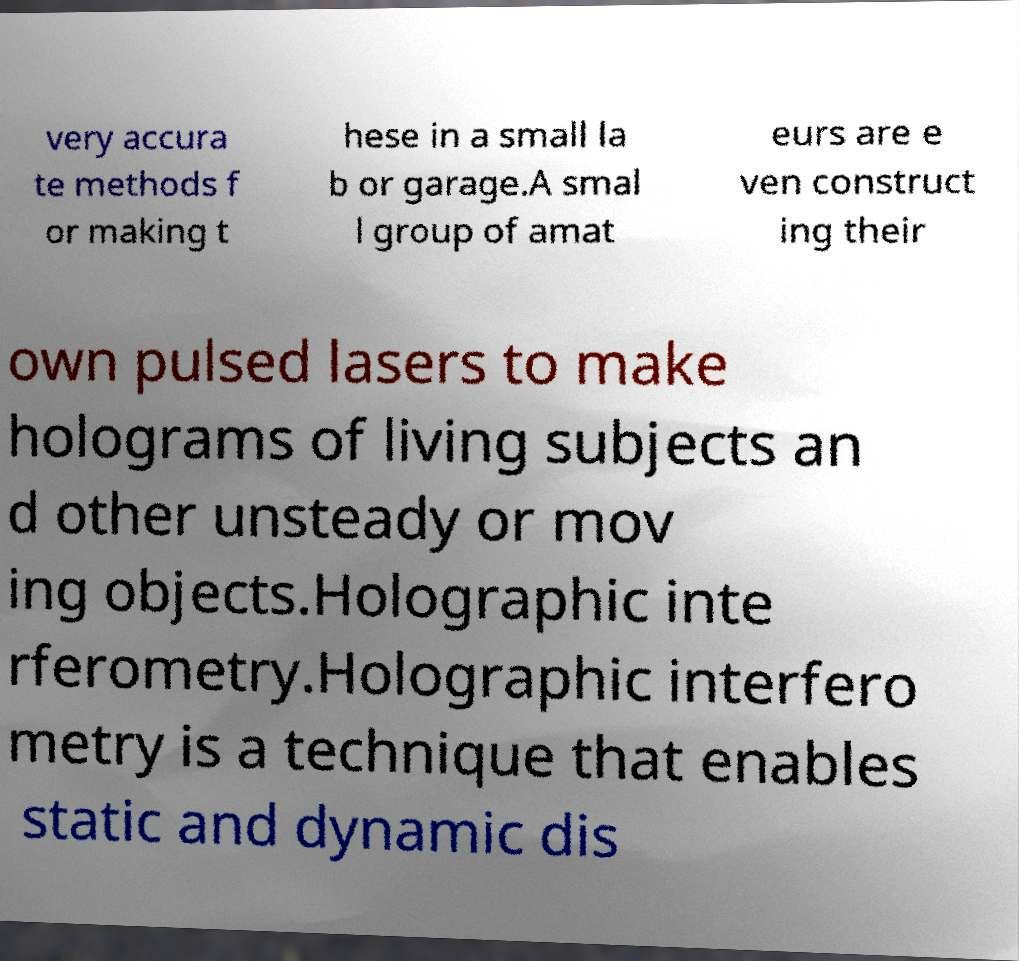I need the written content from this picture converted into text. Can you do that? very accura te methods f or making t hese in a small la b or garage.A smal l group of amat eurs are e ven construct ing their own pulsed lasers to make holograms of living subjects an d other unsteady or mov ing objects.Holographic inte rferometry.Holographic interfero metry is a technique that enables static and dynamic dis 